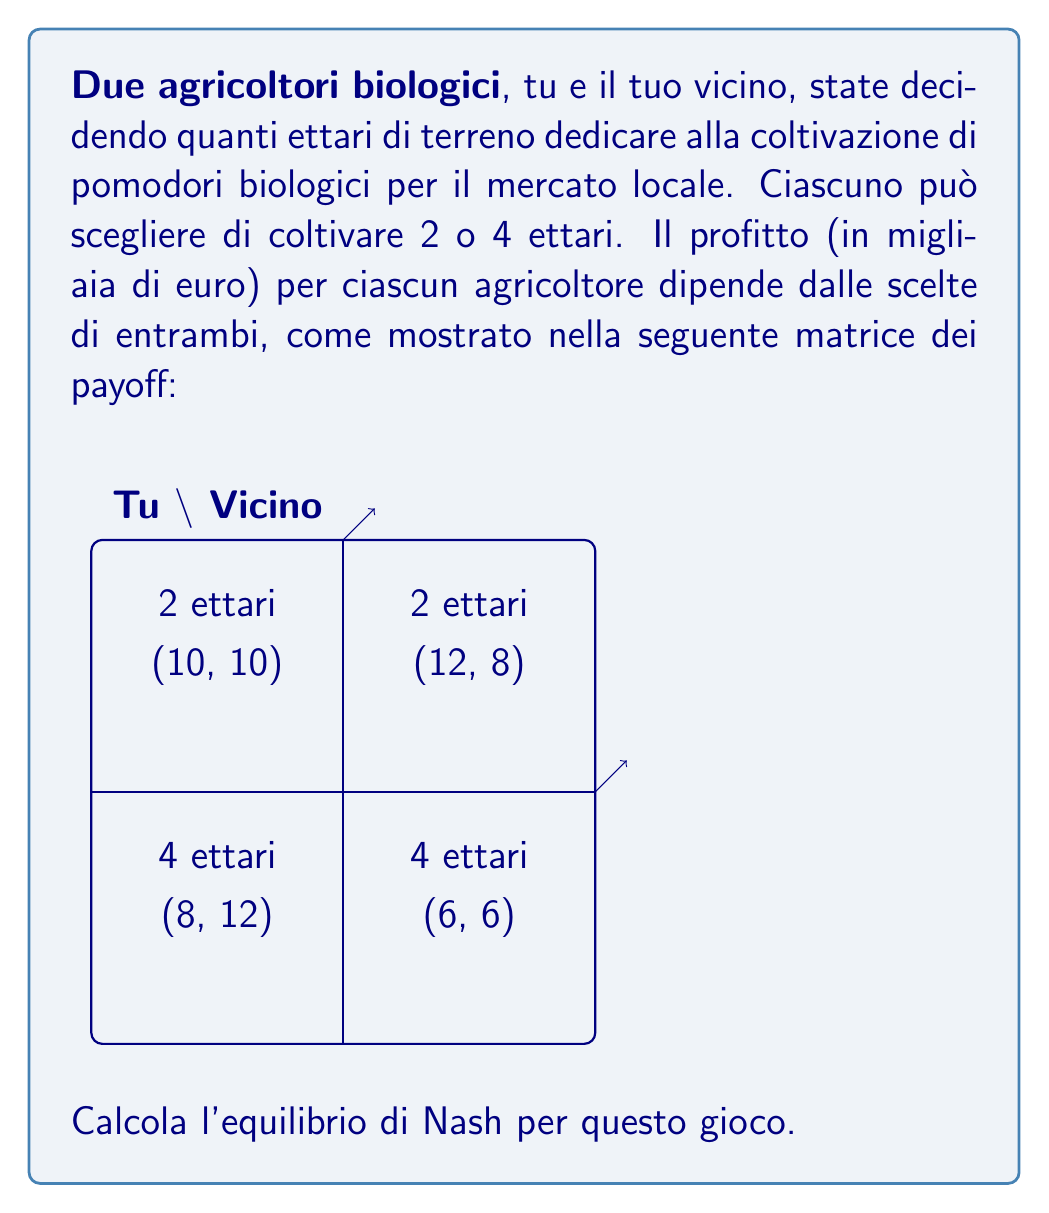Can you answer this question? Per trovare l'equilibrio di Nash, dobbiamo esaminare le strategie dominanti per ciascun agricoltore:

1) Per te:
   - Se il vicino sceglie 2 ettari: 12 > 10, quindi preferisci 4 ettari
   - Se il vicino sceglie 4 ettari: 8 > 6, quindi preferisci 2 ettari
   Non hai una strategia dominante.

2) Per il vicino:
   - Se tu scegli 2 ettari: 12 > 10, quindi preferisce 4 ettari
   - Se tu scegli 4 ettari: 8 > 6, quindi preferisce 2 ettari
   Il vicino non ha una strategia dominante.

3) Verifichiamo le condizioni per l'equilibrio di Nash:
   - (2,2): Non è equilibrio, perché entrambi preferirebbero deviare a 4
   - (2,4): È un equilibrio, nessuno ha incentivo a deviare
   - (4,2): È un equilibrio, nessuno ha incentivo a deviare
   - (4,4): Non è equilibrio, entrambi preferirebbero deviare a 2

Quindi, ci sono due equilibri di Nash in strategie pure: (2,4) e (4,2).

4) In termini di teoria dei giochi, questo è un classico "gioco del pollo", dove la cooperazione (entrambi scelgono 2) sarebbe ottimale, ma c'è un incentivo a "deviare" per ottenere un vantaggio individuale.
Answer: Gli equilibri di Nash sono (2,4) e (4,2). 